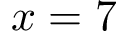<formula> <loc_0><loc_0><loc_500><loc_500>x = 7</formula> 